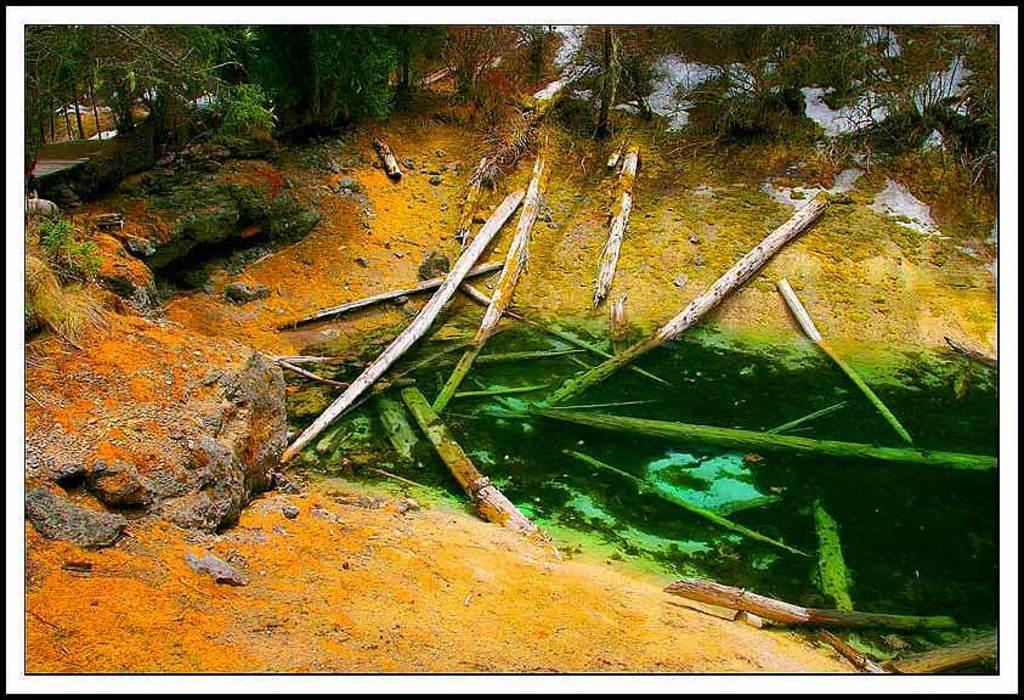What type of material is used to make the objects floating in the water? The objects floating in the water are made of wooden barks. What can be seen in the background of the image? There are trees visible in the image. What type of toothbrush is the man using in the snow in the image? There is no man or toothbrush present in the image, and there is no snow visible. 